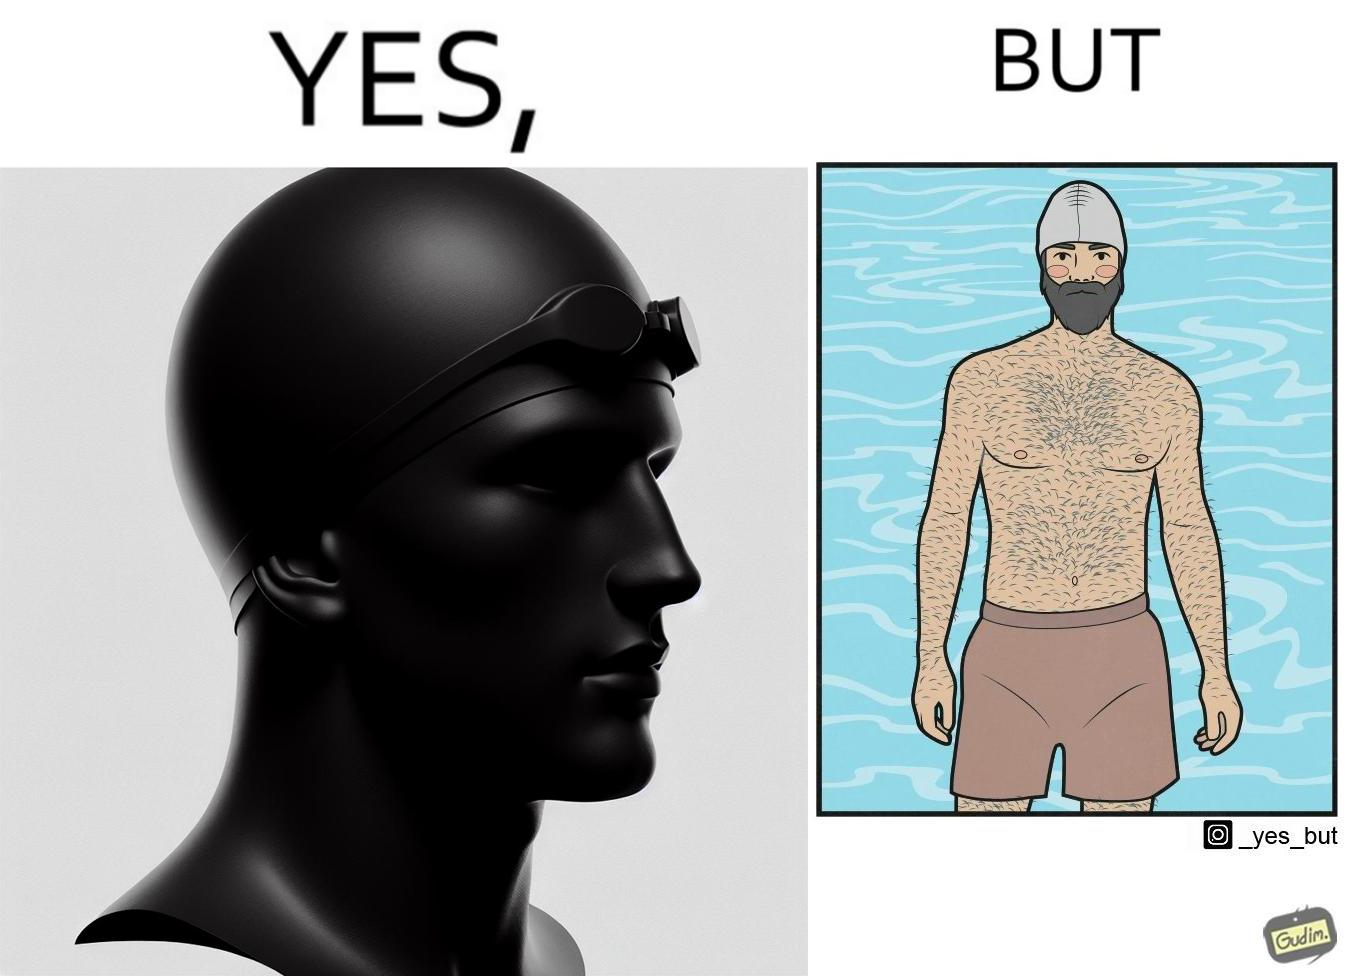Describe what you see in this image. The man is wearing a swimming cap to protect his head's hair but on the other side he is not concerned over the hair all over his body and is nowhere covering them 